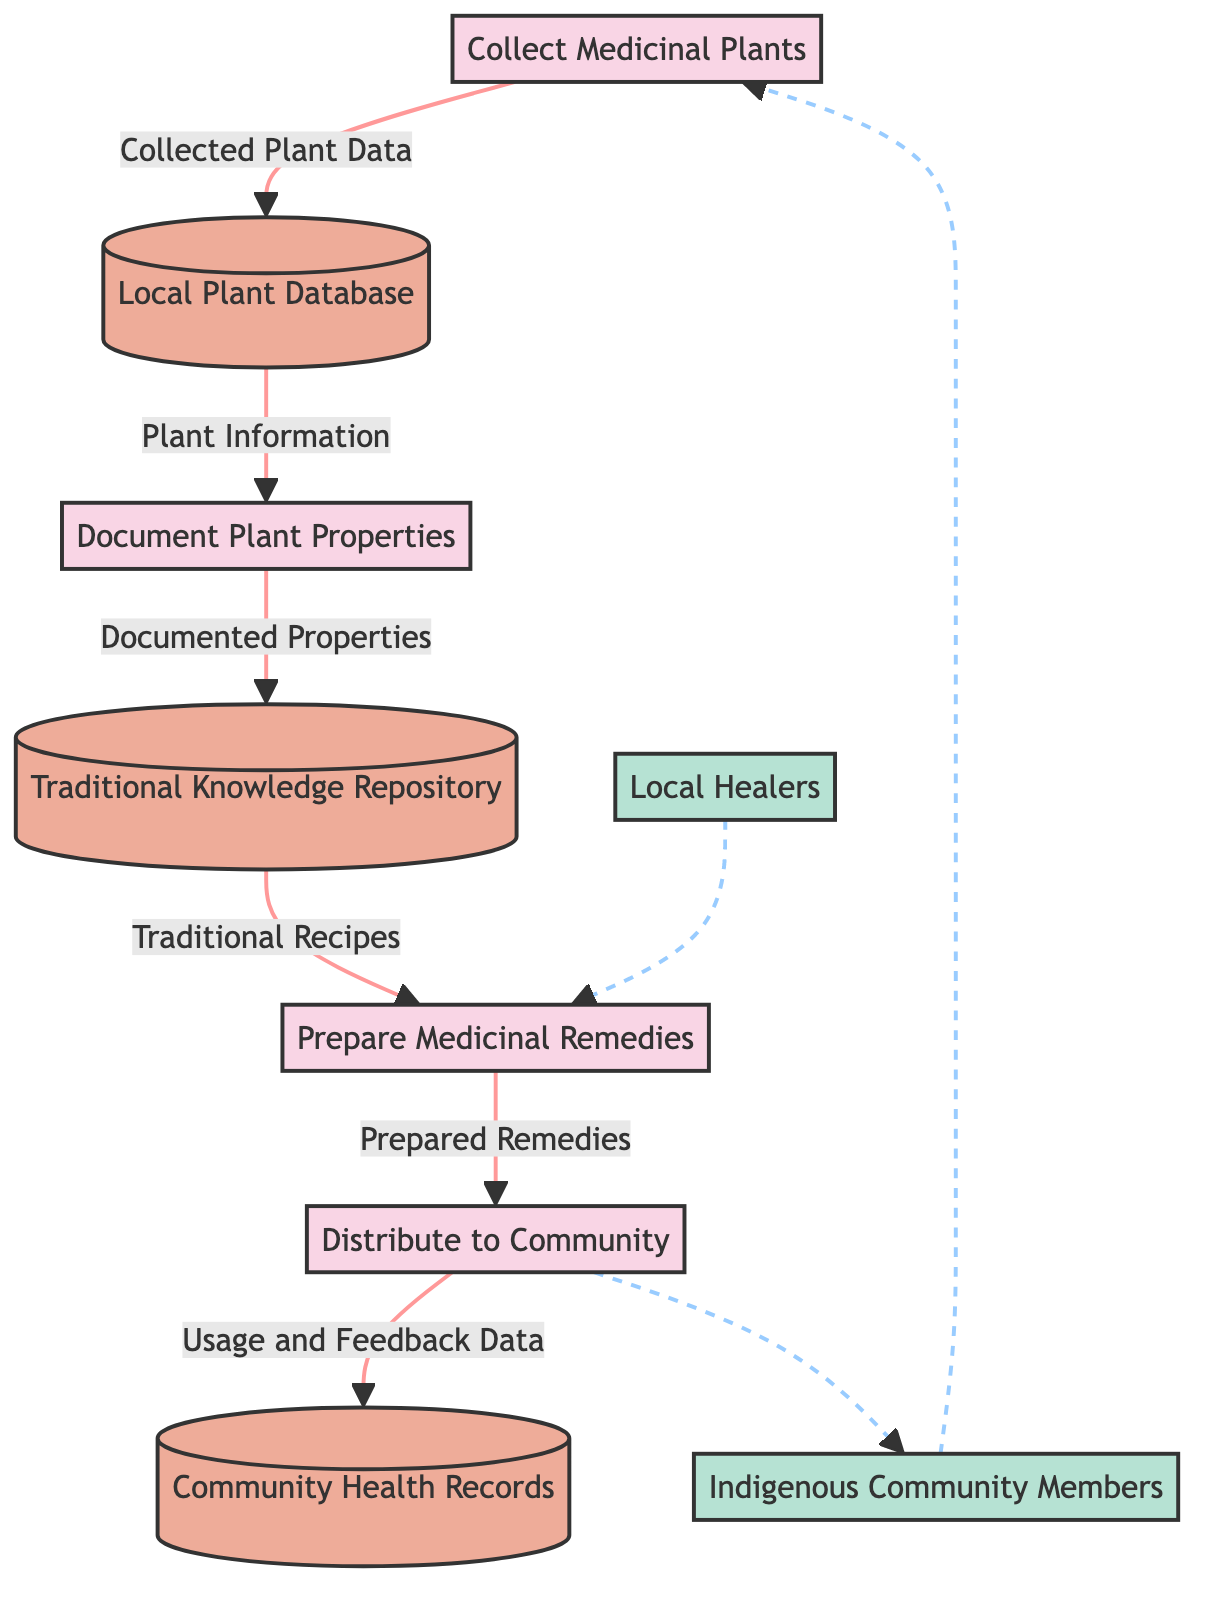What is the first process in the diagram? The diagram lists the processes, and the first one is labeled "Collect Medicinal Plants."
Answer: Collect Medicinal Plants How many data stores are included in the diagram? The diagram shows three data stores: Local Plant Database, Traditional Knowledge Repository, and Community Health Records. Thus, there are three data stores.
Answer: 3 Which process receives data from the "Document Plant Properties"? "Traditional Knowledge Repository" receives data from "Document Plant Properties," as indicated by the arrow going from the process to the data store.
Answer: Traditional Knowledge Repository What type of data is labeled on the flow from "Collect Medicinal Plants" to "Local Plant Database"? The flow from "Collect Medicinal Plants" to "Local Plant Database" is labeled as "Collected Plant Data."
Answer: Collected Plant Data What is the last process in the flow before distributing to the community? The last process before "Distribute to Community" is "Prepare Medicinal Remedies."
Answer: Prepare Medicinal Remedies Where do "Local Healers" contribute in the diagram? "Local Healers" are connected through a dotted line to "Prepare Medicinal Remedies," indicating their role in providing information or feedback to that process.
Answer: Prepare Medicinal Remedies Which data flow ends at the "Community Health Records"? The data flow labeled "Usage and Feedback Data" ends at the "Community Health Records."
Answer: Usage and Feedback Data What type of information flows from "Traditional Knowledge Repository" to "Prepare Medicinal Remedies"? The flow from "Traditional Knowledge Repository" to "Prepare Medicinal Remedies" is labeled "Traditional Recipes."
Answer: Traditional Recipes 